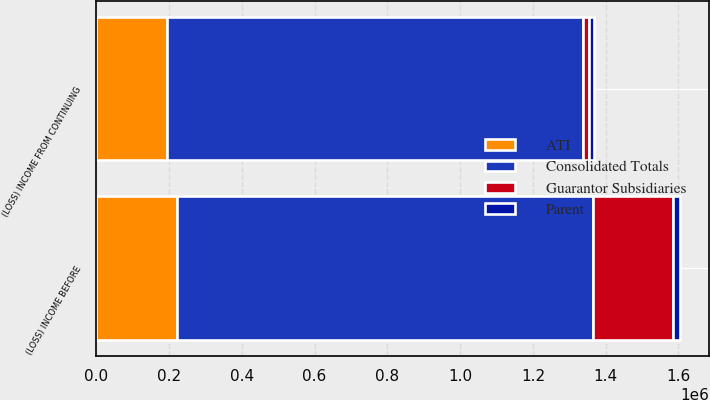Convert chart. <chart><loc_0><loc_0><loc_500><loc_500><stacked_bar_chart><ecel><fcel>(LOSS) INCOME FROM CONTINUING<fcel>(LOSS) INCOME BEFORE<nl><fcel>Consolidated Totals<fcel>1.14188e+06<fcel>1.14188e+06<nl><fcel>ATI<fcel>195441<fcel>222219<nl><fcel>Parent<fcel>15538<fcel>20044<nl><fcel>Guarantor Subsidiaries<fcel>16267<fcel>220185<nl></chart> 